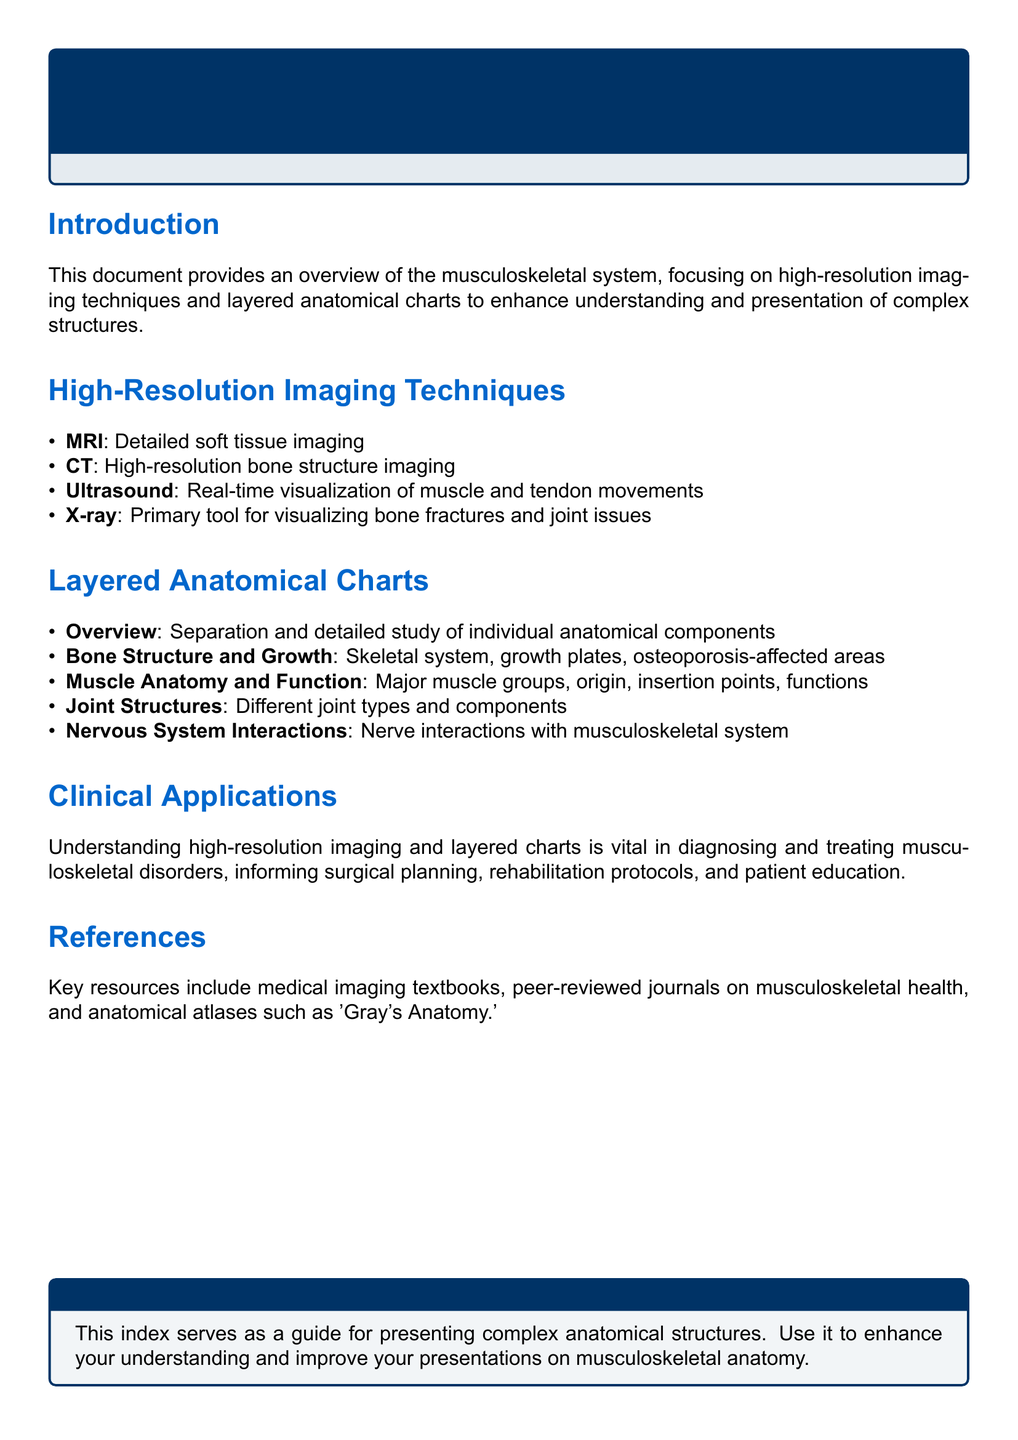What is the focus of the document? The document provides an overview specifically addressing the topics of high-resolution imaging techniques and layered anatomical charts in relation to the musculoskeletal system.
Answer: musculoskeletal system Which imaging technique is used for detailed soft tissue imaging? The document lists MRI as the technique used for detailed soft tissue imaging in the musculoskeletal system.
Answer: MRI What is the primary tool for visualizing bone fractures? The document states that X-ray is the primary tool utilized for visualizing bone fractures and joint issues.
Answer: X-ray Name one clinical application mentioned in the document. The document notes several clinical applications related to musculoskeletal disorders, including diagnosis and surgical planning, which are vital for treatment.
Answer: diagnosis What component does the section on Layered Anatomical Charts overview? The document describes that the overview in the section on Layered Anatomical Charts involves the separation and detailed study of individual anatomical components.
Answer: individual anatomical components Which anatomical atlas is referenced in the document? The document mentions 'Gray's Anatomy' as a key resource in the references section.
Answer: Gray's Anatomy How many imaging techniques are listed in the document? The document enumerates four imaging techniques under High-Resolution Imaging Techniques, contributing to a complete understanding.
Answer: four What aspect of muscle anatomy does the document discuss? The document indicates that the section on Muscle Anatomy and Function covers major muscle groups and their origin and insertion points.
Answer: major muscle groups Which color format is used for the title of the document? The document utilizes an RGB format with specific values assigned to create the title's color, indicated as titlecolor.
Answer: RGB(0,51,102) 